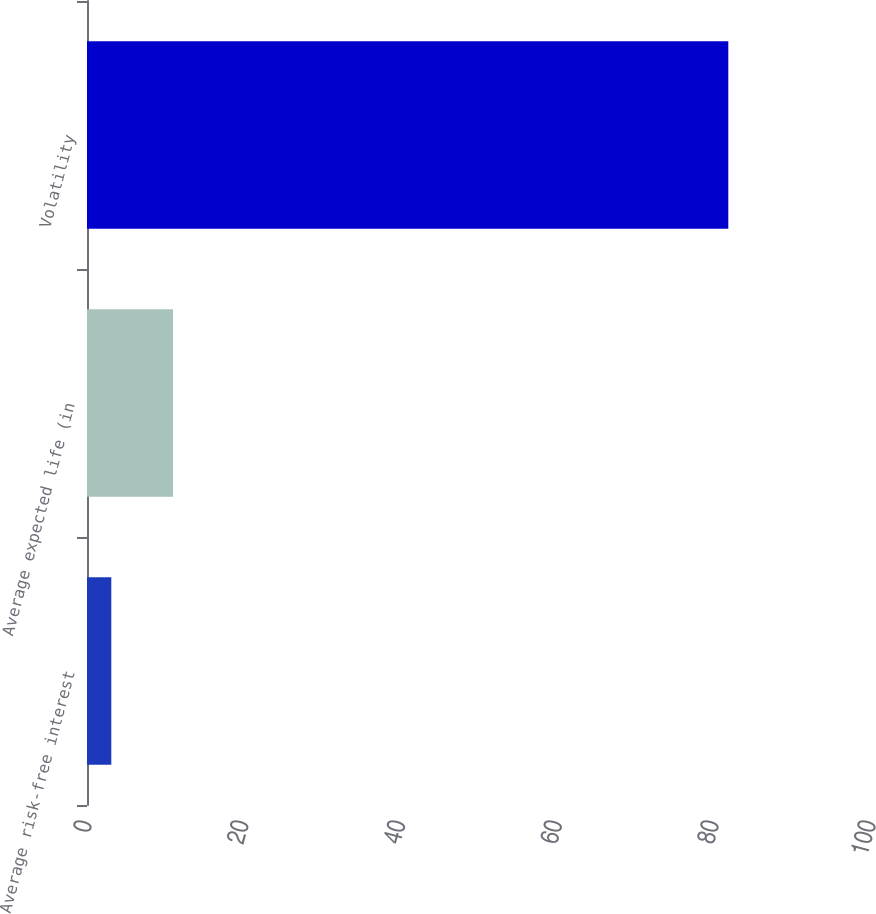<chart> <loc_0><loc_0><loc_500><loc_500><bar_chart><fcel>Average risk-free interest<fcel>Average expected life (in<fcel>Volatility<nl><fcel>3.1<fcel>10.97<fcel>81.8<nl></chart> 